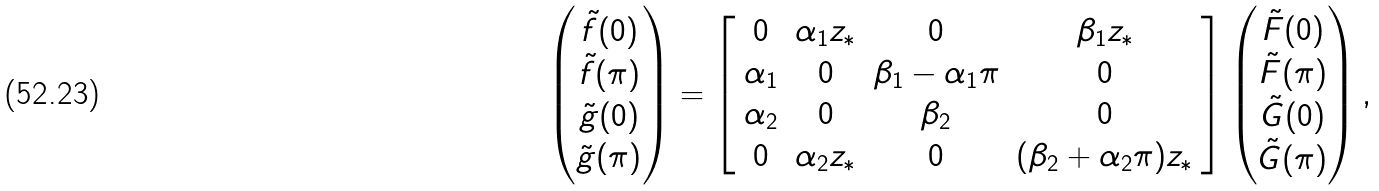<formula> <loc_0><loc_0><loc_500><loc_500>\begin{pmatrix} \tilde { f } ( 0 ) \\ \tilde { f } ( \pi ) \\ \tilde { g } ( 0 ) \\ \tilde { g } ( \pi ) \end{pmatrix} = \left [ \begin{array} { c c c c } 0 & \alpha _ { 1 } z _ { * } & 0 & \beta _ { 1 } z _ { * } \\ \alpha _ { 1 } & 0 & \beta _ { 1 } - \alpha _ { 1 } \pi & 0 \\ \alpha _ { 2 } & 0 & \beta _ { 2 } & 0 \\ 0 & \alpha _ { 2 } z _ { * } & 0 & ( \beta _ { 2 } + \alpha _ { 2 } \pi ) z _ { * } \end{array} \right ] \begin{pmatrix} \tilde { F } ( 0 ) \\ \tilde { F } ( \pi ) \\ \tilde { G } ( 0 ) \\ \tilde { G } ( \pi ) \end{pmatrix} ,</formula> 